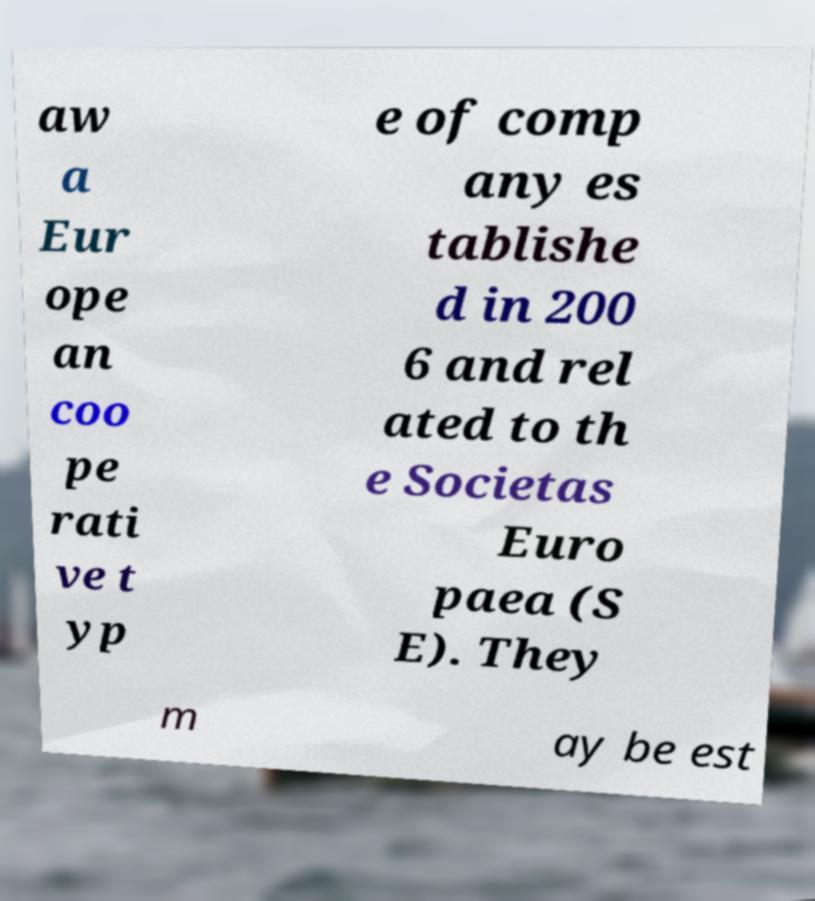I need the written content from this picture converted into text. Can you do that? aw a Eur ope an coo pe rati ve t yp e of comp any es tablishe d in 200 6 and rel ated to th e Societas Euro paea (S E). They m ay be est 